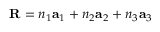<formula> <loc_0><loc_0><loc_500><loc_500>R = n _ { 1 } a _ { 1 } + n _ { 2 } a _ { 2 } + n _ { 3 } a _ { 3 }</formula> 